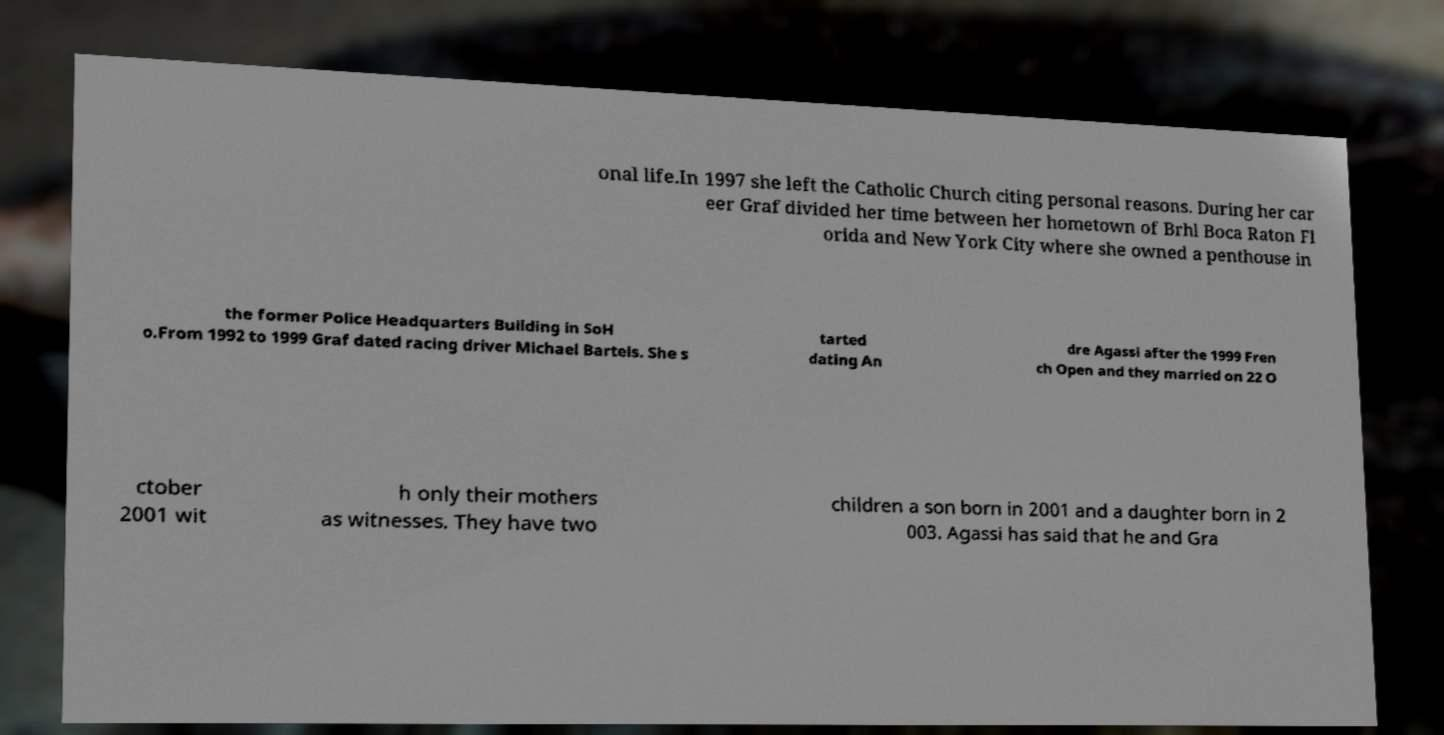Could you extract and type out the text from this image? onal life.In 1997 she left the Catholic Church citing personal reasons. During her car eer Graf divided her time between her hometown of Brhl Boca Raton Fl orida and New York City where she owned a penthouse in the former Police Headquarters Building in SoH o.From 1992 to 1999 Graf dated racing driver Michael Bartels. She s tarted dating An dre Agassi after the 1999 Fren ch Open and they married on 22 O ctober 2001 wit h only their mothers as witnesses. They have two children a son born in 2001 and a daughter born in 2 003. Agassi has said that he and Gra 